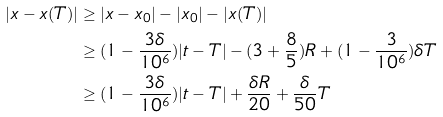<formula> <loc_0><loc_0><loc_500><loc_500>| x - x ( T ) | & \geq | x - x _ { 0 } | - | x _ { 0 } | - | x ( T ) | \\ & \geq ( 1 - \frac { 3 \delta } { 1 0 ^ { 6 } } ) | t - T | - ( 3 + \frac { 8 } { 5 } ) R + ( 1 - \frac { 3 } { 1 0 ^ { 6 } } ) \delta T \\ & \geq ( 1 - \frac { 3 \delta } { 1 0 ^ { 6 } } ) | t - T | + \frac { \delta R } { 2 0 } + \frac { \delta } { 5 0 } T</formula> 